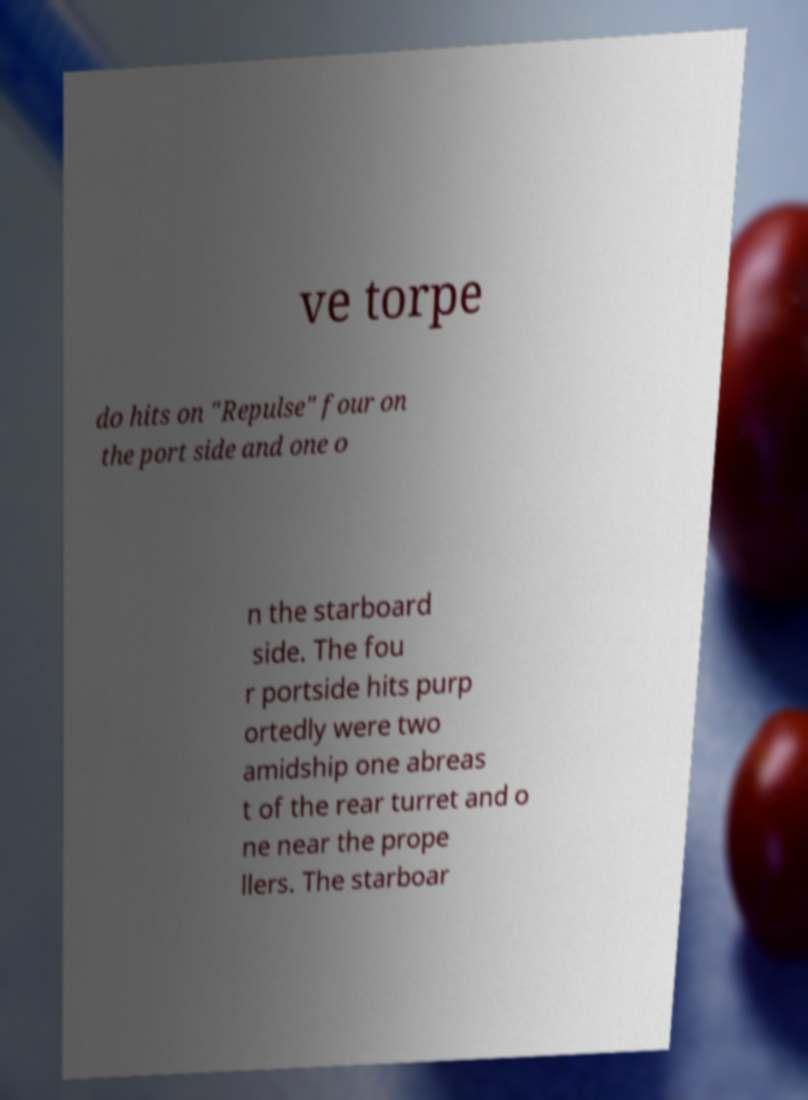Can you read and provide the text displayed in the image?This photo seems to have some interesting text. Can you extract and type it out for me? ve torpe do hits on "Repulse" four on the port side and one o n the starboard side. The fou r portside hits purp ortedly were two amidship one abreas t of the rear turret and o ne near the prope llers. The starboar 